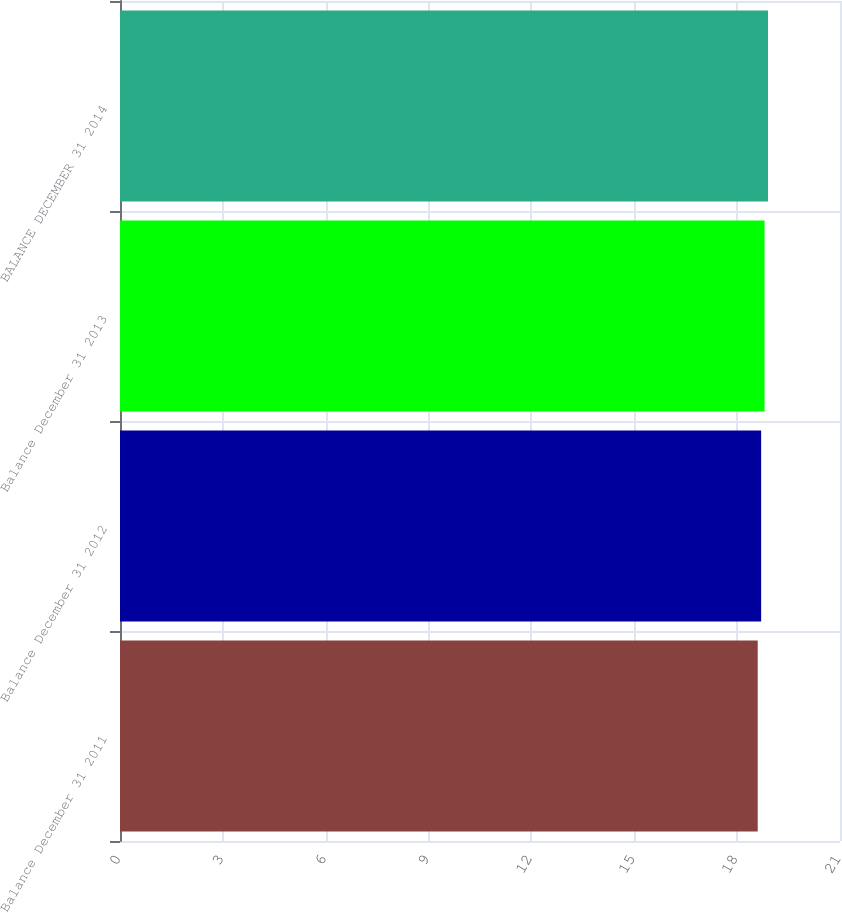<chart> <loc_0><loc_0><loc_500><loc_500><bar_chart><fcel>Balance December 31 2011<fcel>Balance December 31 2012<fcel>Balance December 31 2013<fcel>BALANCE DECEMBER 31 2014<nl><fcel>18.6<fcel>18.7<fcel>18.8<fcel>18.9<nl></chart> 